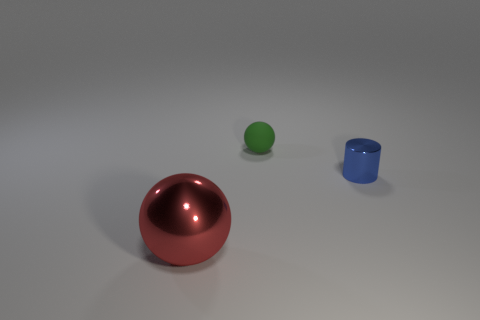Add 2 blue cylinders. How many objects exist? 5 Subtract all balls. How many objects are left? 1 Subtract all tiny purple rubber blocks. Subtract all green matte spheres. How many objects are left? 2 Add 3 large spheres. How many large spheres are left? 4 Add 3 small green metal things. How many small green metal things exist? 3 Subtract 0 yellow cylinders. How many objects are left? 3 